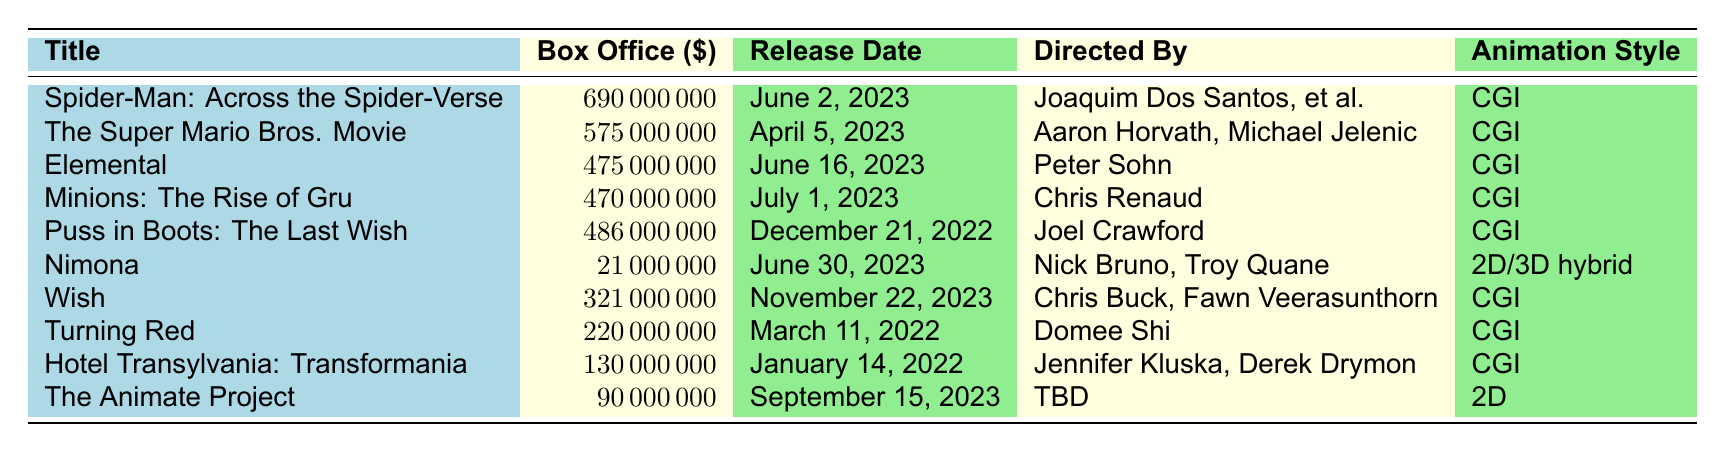What's the highest box office revenue among the top animated films in 2023? The table lists the revenues for each film, and "Spider-Man: Across the Spider-Verse" has the highest amount at 690,000,000.
Answer: 690,000,000 How much more did "The Super Mario Bros. Movie" earn compared to "Nimona"? "The Super Mario Bros. Movie" earned 575,000,000, while "Nimona" earned 21,000,000. The difference is calculated as 575,000,000 - 21,000,000 = 554,000,000.
Answer: 554,000,000 Is "Turning Red" released after "Elemental"? "Turning Red" was released on March 11, 2022, and "Elemental" was released on June 16, 2023; therefore, "Turning Red" was released before "Elemental."
Answer: No What is the total box office revenue of the top 3 animated films? The top 3 films are "Spider-Man: Across the Spider-Verse," "The Super Mario Bros. Movie," and "Elemental." Their revenues sum up to 690,000,000 + 575,000,000 + 475,000,000 = 1,740,000,000.
Answer: 1,740,000,000 Which animated film has the lowest box office revenue, and how much is it? "Nimona" has the lowest revenue listed at 21,000,000.
Answer: Nimona; 21,000,000 What is the average box office revenue of all the films listed in the table? To calculate the average, first add all revenues: 690,000,000 + 575,000,000 + 475,000,000 + 470,000,000 + 486,000,000 + 21,000,000 + 321,000,000 + 220,000,000 + 130,000,000 + 90,000,000 = 3,468,000,000. Then divide by the number of films (10): 3,468,000,000 / 10 = 346,800,000.
Answer: 346,800,000 How many of the top animated films in 2023 were directed by duo teams (two or more directors)? The films directed by two or more directors are "Spider-Man: Across the Spider-Verse" and "Nimona." The count is 2.
Answer: 2 Does any animated film in the table utilize 2D animation? "Nimona" uses a 2D/3D hybrid animation style while "The Animate Project" uses 2D animation, both indicating that 2D animation is used in the table.
Answer: Yes What is the difference in revenue between the highest earning and second highest earning animated films? The highest earner is "Spider-Man: Across the Spider-Verse" with 690,000,000, and the second is "The Super Mario Bros. Movie" with 575,000,000. The difference is 690,000,000 - 575,000,000 = 115,000,000.
Answer: 115,000,000 Identify the film directed by Chris Buck and its box office earnings. The film directed by Chris Buck is "Wish," which has earnings of 321,000,000.
Answer: Wish; 321,000,000 Which animation style is most common among the top animated films? The majority of films listed, specifically 8 out of 10, are using CGI animation style, making it the most common.
Answer: CGI 